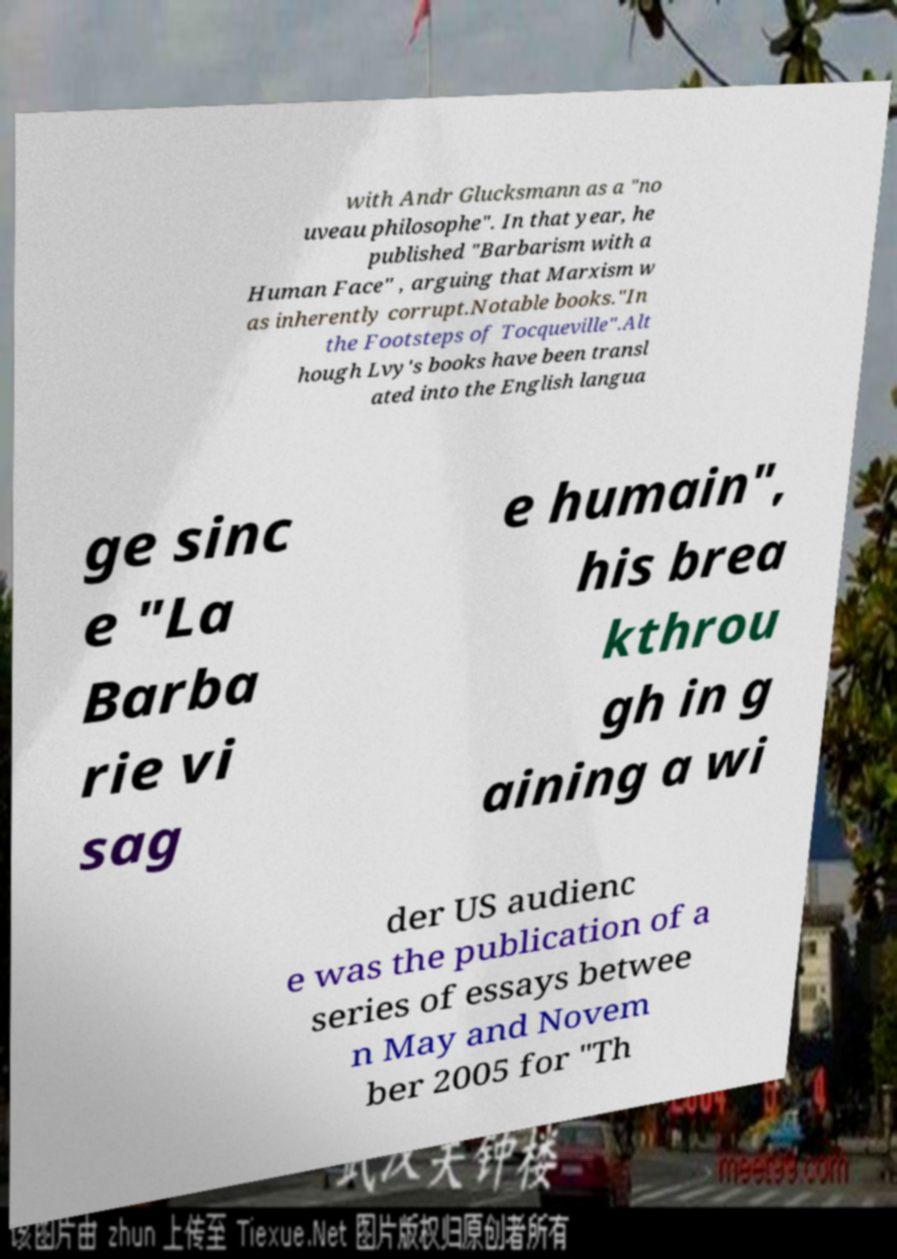Please identify and transcribe the text found in this image. with Andr Glucksmann as a "no uveau philosophe". In that year, he published "Barbarism with a Human Face" , arguing that Marxism w as inherently corrupt.Notable books."In the Footsteps of Tocqueville".Alt hough Lvy's books have been transl ated into the English langua ge sinc e "La Barba rie vi sag e humain", his brea kthrou gh in g aining a wi der US audienc e was the publication of a series of essays betwee n May and Novem ber 2005 for "Th 